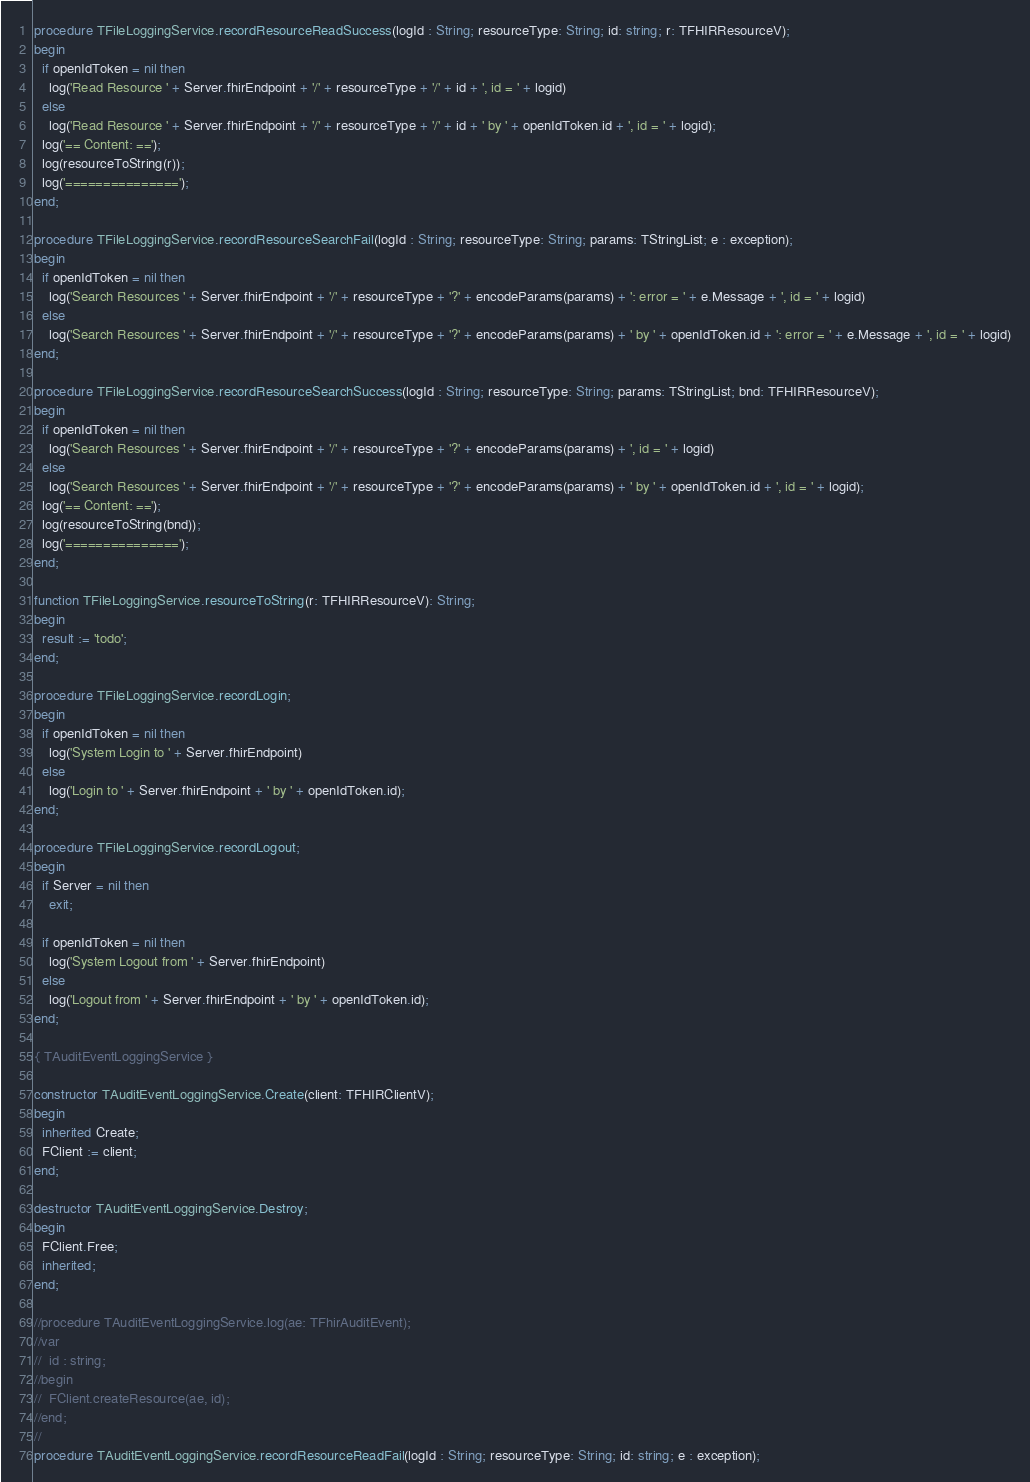Convert code to text. <code><loc_0><loc_0><loc_500><loc_500><_Pascal_>procedure TFileLoggingService.recordResourceReadSuccess(logId : String; resourceType: String; id: string; r: TFHIRResourceV);
begin
  if openIdToken = nil then
    log('Read Resource ' + Server.fhirEndpoint + '/' + resourceType + '/' + id + ', id = ' + logid)
  else
    log('Read Resource ' + Server.fhirEndpoint + '/' + resourceType + '/' + id + ' by ' + openIdToken.id + ', id = ' + logid);
  log('== Content: ==');
  log(resourceToString(r));
  log('===============');
end;

procedure TFileLoggingService.recordResourceSearchFail(logId : String; resourceType: String; params: TStringList; e : exception);
begin
  if openIdToken = nil then
    log('Search Resources ' + Server.fhirEndpoint + '/' + resourceType + '?' + encodeParams(params) + ': error = ' + e.Message + ', id = ' + logid)
  else
    log('Search Resources ' + Server.fhirEndpoint + '/' + resourceType + '?' + encodeParams(params) + ' by ' + openIdToken.id + ': error = ' + e.Message + ', id = ' + logid)
end;

procedure TFileLoggingService.recordResourceSearchSuccess(logId : String; resourceType: String; params: TStringList; bnd: TFHIRResourceV);
begin
  if openIdToken = nil then
    log('Search Resources ' + Server.fhirEndpoint + '/' + resourceType + '?' + encodeParams(params) + ', id = ' + logid)
  else
    log('Search Resources ' + Server.fhirEndpoint + '/' + resourceType + '?' + encodeParams(params) + ' by ' + openIdToken.id + ', id = ' + logid);
  log('== Content: ==');
  log(resourceToString(bnd));
  log('===============');
end;

function TFileLoggingService.resourceToString(r: TFHIRResourceV): String;
begin
  result := 'todo';
end;

procedure TFileLoggingService.recordLogin;
begin
  if openIdToken = nil then
    log('System Login to ' + Server.fhirEndpoint)
  else
    log('Login to ' + Server.fhirEndpoint + ' by ' + openIdToken.id);
end;

procedure TFileLoggingService.recordLogout;
begin
  if Server = nil then
    exit;

  if openIdToken = nil then
    log('System Logout from ' + Server.fhirEndpoint)
  else
    log('Logout from ' + Server.fhirEndpoint + ' by ' + openIdToken.id);
end;

{ TAuditEventLoggingService }

constructor TAuditEventLoggingService.Create(client: TFHIRClientV);
begin
  inherited Create;
  FClient := client;
end;

destructor TAuditEventLoggingService.Destroy;
begin
  FClient.Free;
  inherited;
end;

//procedure TAuditEventLoggingService.log(ae: TFhirAuditEvent);
//var
//  id : string;
//begin
//  FClient.createResource(ae, id);
//end;
//
procedure TAuditEventLoggingService.recordResourceReadFail(logId : String; resourceType: String; id: string; e : exception);</code> 